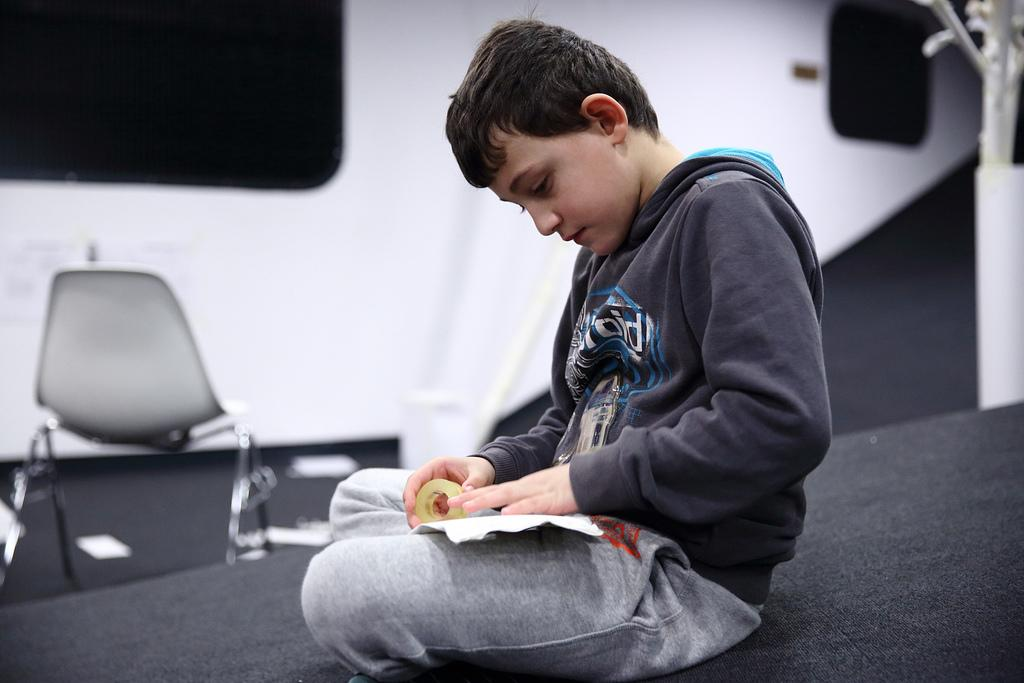What is the main subject of the image? The main subject of the image is a boy. What is the boy doing in the image? The boy is sitting in the image. What is the boy holding in his hands? The boy is holding something in his hands, but the specific object is not mentioned in the facts. What can be seen in the background of the image? There is a chair in the background of the image. What language is the boy speaking in the image? The facts provided do not mention any language spoken by the boy in the image. Is the boy experiencing any signs of death in the image? There is no indication of death or any related signs in the image. 